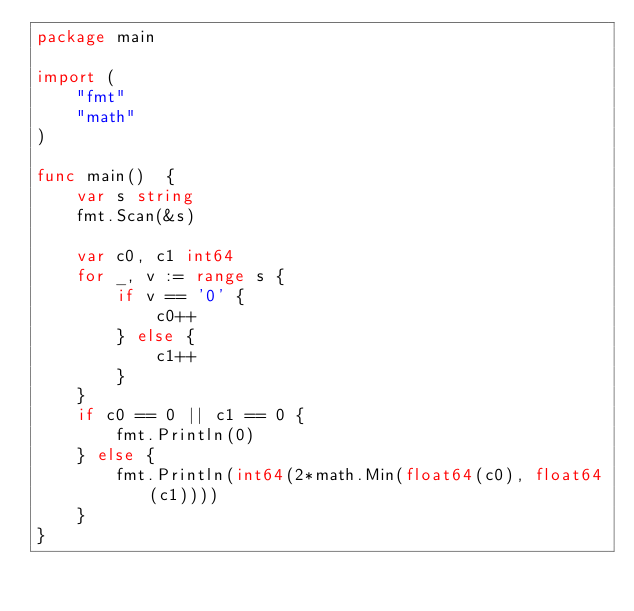<code> <loc_0><loc_0><loc_500><loc_500><_Go_>package main

import (
	"fmt"
	"math"
)

func main()  {
	var s string
	fmt.Scan(&s)

	var c0, c1 int64
	for _, v := range s {
		if v == '0' {
			c0++
		} else {
			c1++
		}
	}
	if c0 == 0 || c1 == 0 {
		fmt.Println(0)
	} else {
		fmt.Println(int64(2*math.Min(float64(c0), float64(c1))))
	}
}</code> 